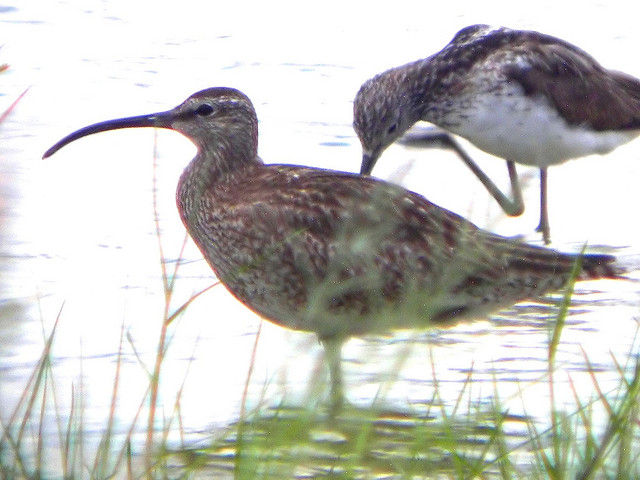<image>What type of birds are they? I don't know what type of birds they are. They could be seagulls, doves, kingfishers, or even cranes. What type of birds are they? I don't know what type of birds they are. It can be seagulls, dove, kingfishers, seagull, water birds, cranes, rail, peregrine or seagull. 